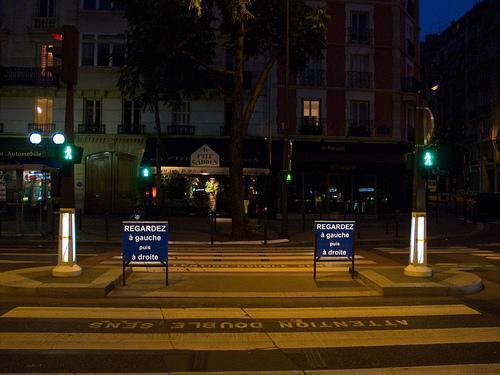What language is probably spoken in this locale?
Pick the correct solution from the four options below to address the question.
Options: Spanish, italian, french, portuguese. French. 